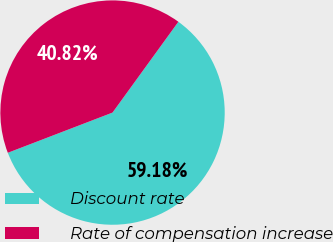<chart> <loc_0><loc_0><loc_500><loc_500><pie_chart><fcel>Discount rate<fcel>Rate of compensation increase<nl><fcel>59.18%<fcel>40.82%<nl></chart> 